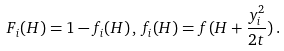Convert formula to latex. <formula><loc_0><loc_0><loc_500><loc_500>F _ { i } ( H ) = 1 - f _ { i } ( H ) \, , \, f _ { i } ( H ) = f ( H + \frac { { y } _ { i } ^ { 2 } } { 2 t } ) \, .</formula> 